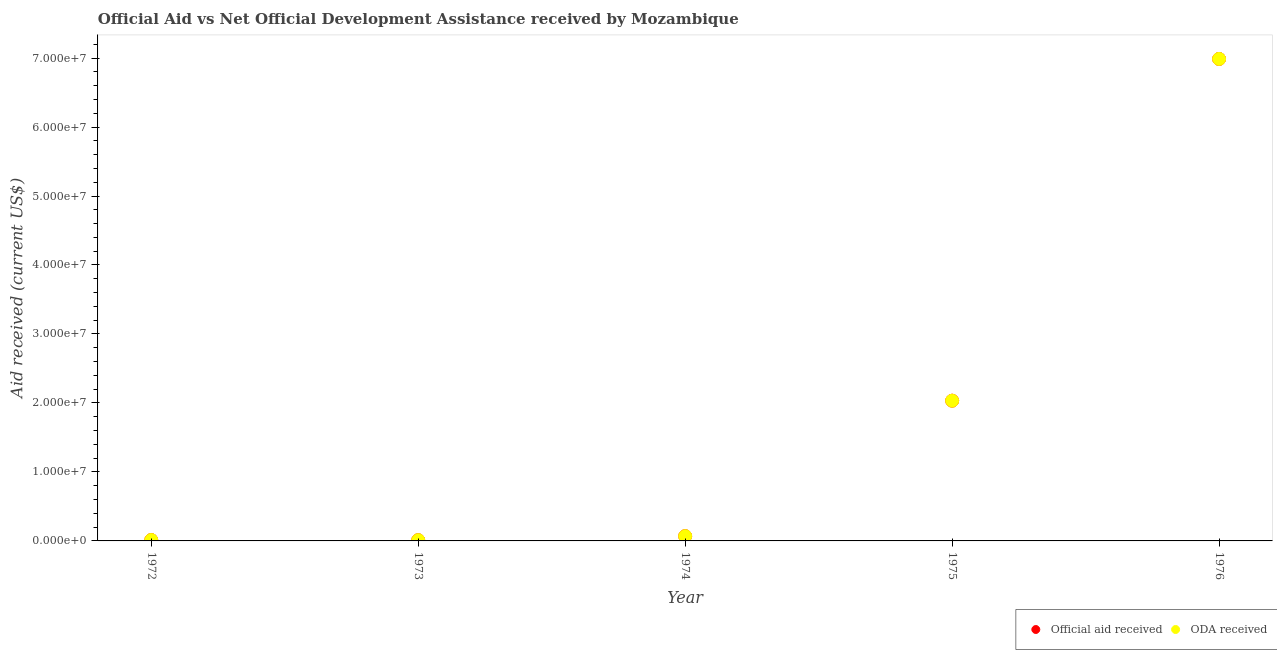What is the official aid received in 1972?
Provide a short and direct response. 1.30e+05. Across all years, what is the maximum official aid received?
Provide a short and direct response. 6.99e+07. Across all years, what is the minimum oda received?
Your answer should be very brief. 1.10e+05. In which year was the official aid received maximum?
Your answer should be compact. 1976. What is the total official aid received in the graph?
Offer a terse response. 9.11e+07. What is the difference between the oda received in 1973 and that in 1976?
Ensure brevity in your answer.  -6.98e+07. What is the difference between the oda received in 1975 and the official aid received in 1976?
Your answer should be very brief. -4.95e+07. What is the average official aid received per year?
Offer a very short reply. 1.82e+07. In the year 1972, what is the difference between the official aid received and oda received?
Keep it short and to the point. 0. In how many years, is the oda received greater than 16000000 US$?
Keep it short and to the point. 2. What is the ratio of the oda received in 1972 to that in 1976?
Your answer should be very brief. 0. What is the difference between the highest and the second highest official aid received?
Your answer should be very brief. 4.95e+07. What is the difference between the highest and the lowest official aid received?
Provide a succinct answer. 6.98e+07. Are the values on the major ticks of Y-axis written in scientific E-notation?
Provide a short and direct response. Yes. Does the graph contain grids?
Provide a short and direct response. No. How many legend labels are there?
Your answer should be very brief. 2. How are the legend labels stacked?
Provide a succinct answer. Horizontal. What is the title of the graph?
Provide a short and direct response. Official Aid vs Net Official Development Assistance received by Mozambique . Does "ODA received" appear as one of the legend labels in the graph?
Give a very brief answer. Yes. What is the label or title of the Y-axis?
Provide a short and direct response. Aid received (current US$). What is the Aid received (current US$) in Official aid received in 1972?
Provide a short and direct response. 1.30e+05. What is the Aid received (current US$) in ODA received in 1972?
Keep it short and to the point. 1.30e+05. What is the Aid received (current US$) in Official aid received in 1974?
Provide a short and direct response. 6.90e+05. What is the Aid received (current US$) in ODA received in 1974?
Keep it short and to the point. 6.90e+05. What is the Aid received (current US$) of Official aid received in 1975?
Offer a very short reply. 2.03e+07. What is the Aid received (current US$) of ODA received in 1975?
Provide a succinct answer. 2.03e+07. What is the Aid received (current US$) in Official aid received in 1976?
Provide a short and direct response. 6.99e+07. What is the Aid received (current US$) in ODA received in 1976?
Offer a terse response. 6.99e+07. Across all years, what is the maximum Aid received (current US$) of Official aid received?
Provide a succinct answer. 6.99e+07. Across all years, what is the maximum Aid received (current US$) of ODA received?
Keep it short and to the point. 6.99e+07. What is the total Aid received (current US$) of Official aid received in the graph?
Offer a terse response. 9.11e+07. What is the total Aid received (current US$) of ODA received in the graph?
Provide a succinct answer. 9.11e+07. What is the difference between the Aid received (current US$) of Official aid received in 1972 and that in 1974?
Your answer should be very brief. -5.60e+05. What is the difference between the Aid received (current US$) of ODA received in 1972 and that in 1974?
Your response must be concise. -5.60e+05. What is the difference between the Aid received (current US$) in Official aid received in 1972 and that in 1975?
Offer a terse response. -2.02e+07. What is the difference between the Aid received (current US$) in ODA received in 1972 and that in 1975?
Provide a short and direct response. -2.02e+07. What is the difference between the Aid received (current US$) of Official aid received in 1972 and that in 1976?
Offer a terse response. -6.97e+07. What is the difference between the Aid received (current US$) in ODA received in 1972 and that in 1976?
Provide a succinct answer. -6.97e+07. What is the difference between the Aid received (current US$) in Official aid received in 1973 and that in 1974?
Keep it short and to the point. -5.80e+05. What is the difference between the Aid received (current US$) of ODA received in 1973 and that in 1974?
Give a very brief answer. -5.80e+05. What is the difference between the Aid received (current US$) in Official aid received in 1973 and that in 1975?
Provide a succinct answer. -2.02e+07. What is the difference between the Aid received (current US$) of ODA received in 1973 and that in 1975?
Give a very brief answer. -2.02e+07. What is the difference between the Aid received (current US$) in Official aid received in 1973 and that in 1976?
Provide a succinct answer. -6.98e+07. What is the difference between the Aid received (current US$) in ODA received in 1973 and that in 1976?
Offer a very short reply. -6.98e+07. What is the difference between the Aid received (current US$) in Official aid received in 1974 and that in 1975?
Make the answer very short. -1.96e+07. What is the difference between the Aid received (current US$) in ODA received in 1974 and that in 1975?
Make the answer very short. -1.96e+07. What is the difference between the Aid received (current US$) in Official aid received in 1974 and that in 1976?
Offer a terse response. -6.92e+07. What is the difference between the Aid received (current US$) in ODA received in 1974 and that in 1976?
Offer a terse response. -6.92e+07. What is the difference between the Aid received (current US$) of Official aid received in 1975 and that in 1976?
Ensure brevity in your answer.  -4.95e+07. What is the difference between the Aid received (current US$) in ODA received in 1975 and that in 1976?
Ensure brevity in your answer.  -4.95e+07. What is the difference between the Aid received (current US$) in Official aid received in 1972 and the Aid received (current US$) in ODA received in 1974?
Give a very brief answer. -5.60e+05. What is the difference between the Aid received (current US$) of Official aid received in 1972 and the Aid received (current US$) of ODA received in 1975?
Your answer should be very brief. -2.02e+07. What is the difference between the Aid received (current US$) of Official aid received in 1972 and the Aid received (current US$) of ODA received in 1976?
Make the answer very short. -6.97e+07. What is the difference between the Aid received (current US$) in Official aid received in 1973 and the Aid received (current US$) in ODA received in 1974?
Your response must be concise. -5.80e+05. What is the difference between the Aid received (current US$) in Official aid received in 1973 and the Aid received (current US$) in ODA received in 1975?
Your answer should be very brief. -2.02e+07. What is the difference between the Aid received (current US$) in Official aid received in 1973 and the Aid received (current US$) in ODA received in 1976?
Keep it short and to the point. -6.98e+07. What is the difference between the Aid received (current US$) of Official aid received in 1974 and the Aid received (current US$) of ODA received in 1975?
Your answer should be compact. -1.96e+07. What is the difference between the Aid received (current US$) of Official aid received in 1974 and the Aid received (current US$) of ODA received in 1976?
Offer a very short reply. -6.92e+07. What is the difference between the Aid received (current US$) of Official aid received in 1975 and the Aid received (current US$) of ODA received in 1976?
Your answer should be very brief. -4.95e+07. What is the average Aid received (current US$) of Official aid received per year?
Make the answer very short. 1.82e+07. What is the average Aid received (current US$) in ODA received per year?
Make the answer very short. 1.82e+07. In the year 1973, what is the difference between the Aid received (current US$) of Official aid received and Aid received (current US$) of ODA received?
Offer a very short reply. 0. In the year 1974, what is the difference between the Aid received (current US$) of Official aid received and Aid received (current US$) of ODA received?
Your response must be concise. 0. In the year 1976, what is the difference between the Aid received (current US$) of Official aid received and Aid received (current US$) of ODA received?
Offer a very short reply. 0. What is the ratio of the Aid received (current US$) of Official aid received in 1972 to that in 1973?
Offer a very short reply. 1.18. What is the ratio of the Aid received (current US$) in ODA received in 1972 to that in 1973?
Your answer should be compact. 1.18. What is the ratio of the Aid received (current US$) in Official aid received in 1972 to that in 1974?
Provide a succinct answer. 0.19. What is the ratio of the Aid received (current US$) of ODA received in 1972 to that in 1974?
Offer a very short reply. 0.19. What is the ratio of the Aid received (current US$) in Official aid received in 1972 to that in 1975?
Provide a succinct answer. 0.01. What is the ratio of the Aid received (current US$) in ODA received in 1972 to that in 1975?
Ensure brevity in your answer.  0.01. What is the ratio of the Aid received (current US$) of Official aid received in 1972 to that in 1976?
Offer a very short reply. 0. What is the ratio of the Aid received (current US$) of ODA received in 1972 to that in 1976?
Offer a terse response. 0. What is the ratio of the Aid received (current US$) in Official aid received in 1973 to that in 1974?
Offer a very short reply. 0.16. What is the ratio of the Aid received (current US$) of ODA received in 1973 to that in 1974?
Your answer should be very brief. 0.16. What is the ratio of the Aid received (current US$) in Official aid received in 1973 to that in 1975?
Make the answer very short. 0.01. What is the ratio of the Aid received (current US$) in ODA received in 1973 to that in 1975?
Give a very brief answer. 0.01. What is the ratio of the Aid received (current US$) of Official aid received in 1973 to that in 1976?
Make the answer very short. 0. What is the ratio of the Aid received (current US$) of ODA received in 1973 to that in 1976?
Make the answer very short. 0. What is the ratio of the Aid received (current US$) of Official aid received in 1974 to that in 1975?
Provide a short and direct response. 0.03. What is the ratio of the Aid received (current US$) of ODA received in 1974 to that in 1975?
Provide a succinct answer. 0.03. What is the ratio of the Aid received (current US$) of Official aid received in 1974 to that in 1976?
Ensure brevity in your answer.  0.01. What is the ratio of the Aid received (current US$) in ODA received in 1974 to that in 1976?
Keep it short and to the point. 0.01. What is the ratio of the Aid received (current US$) of Official aid received in 1975 to that in 1976?
Give a very brief answer. 0.29. What is the ratio of the Aid received (current US$) of ODA received in 1975 to that in 1976?
Make the answer very short. 0.29. What is the difference between the highest and the second highest Aid received (current US$) in Official aid received?
Keep it short and to the point. 4.95e+07. What is the difference between the highest and the second highest Aid received (current US$) in ODA received?
Your answer should be compact. 4.95e+07. What is the difference between the highest and the lowest Aid received (current US$) of Official aid received?
Your response must be concise. 6.98e+07. What is the difference between the highest and the lowest Aid received (current US$) in ODA received?
Ensure brevity in your answer.  6.98e+07. 